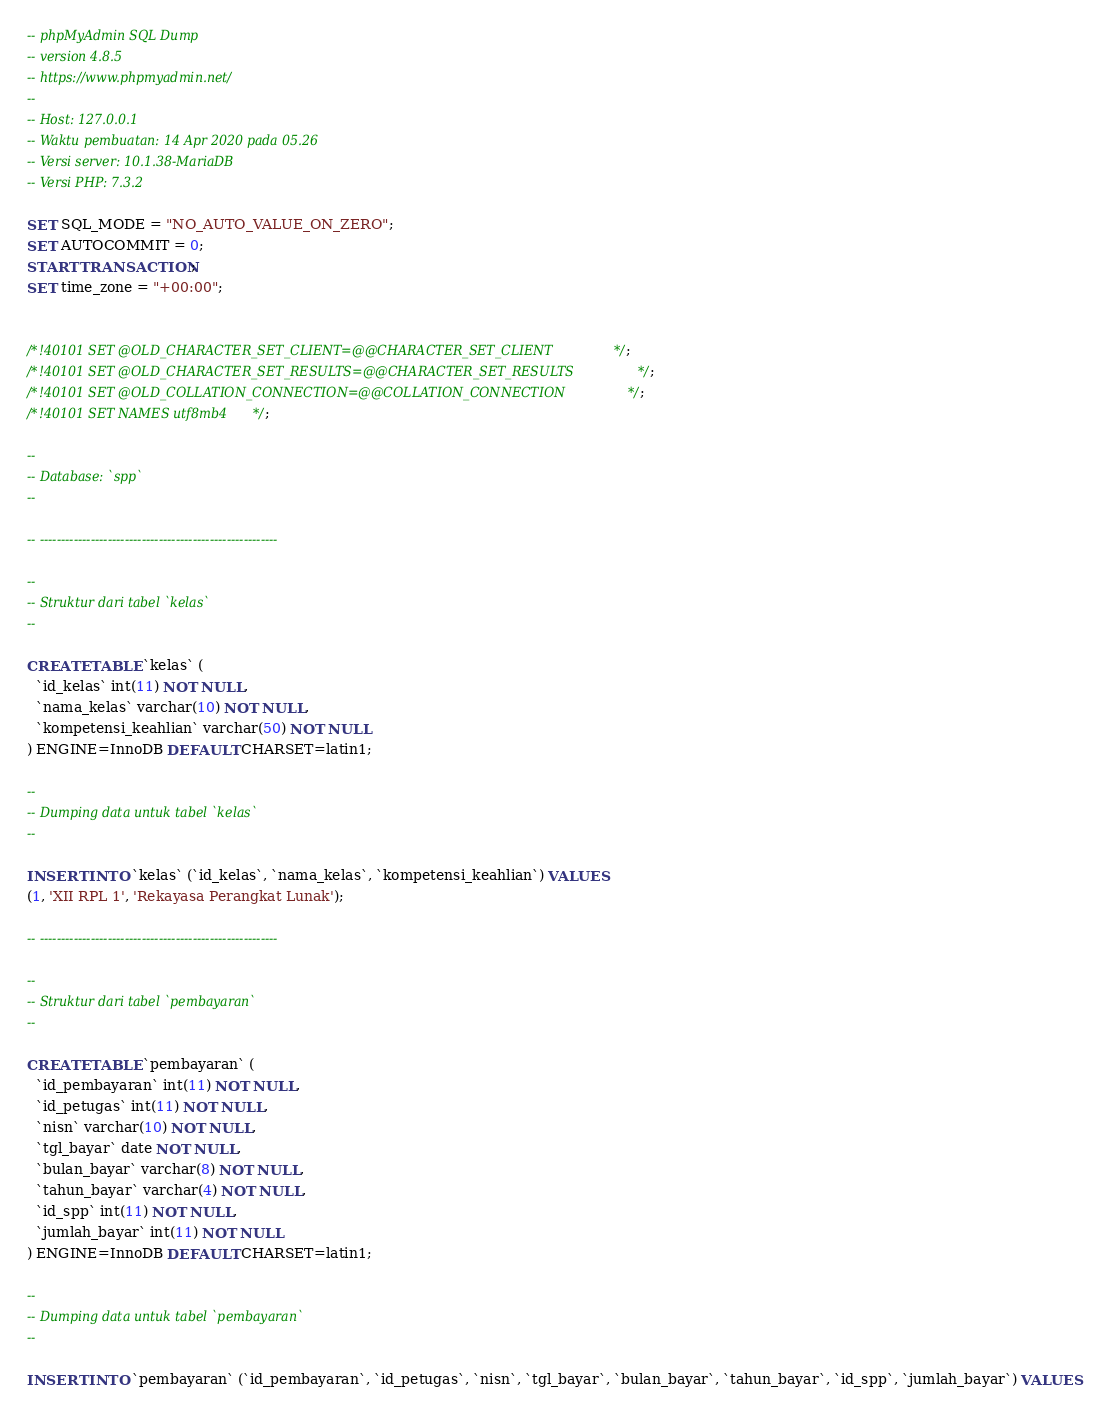<code> <loc_0><loc_0><loc_500><loc_500><_SQL_>-- phpMyAdmin SQL Dump
-- version 4.8.5
-- https://www.phpmyadmin.net/
--
-- Host: 127.0.0.1
-- Waktu pembuatan: 14 Apr 2020 pada 05.26
-- Versi server: 10.1.38-MariaDB
-- Versi PHP: 7.3.2

SET SQL_MODE = "NO_AUTO_VALUE_ON_ZERO";
SET AUTOCOMMIT = 0;
START TRANSACTION;
SET time_zone = "+00:00";


/*!40101 SET @OLD_CHARACTER_SET_CLIENT=@@CHARACTER_SET_CLIENT */;
/*!40101 SET @OLD_CHARACTER_SET_RESULTS=@@CHARACTER_SET_RESULTS */;
/*!40101 SET @OLD_COLLATION_CONNECTION=@@COLLATION_CONNECTION */;
/*!40101 SET NAMES utf8mb4 */;

--
-- Database: `spp`
--

-- --------------------------------------------------------

--
-- Struktur dari tabel `kelas`
--

CREATE TABLE `kelas` (
  `id_kelas` int(11) NOT NULL,
  `nama_kelas` varchar(10) NOT NULL,
  `kompetensi_keahlian` varchar(50) NOT NULL
) ENGINE=InnoDB DEFAULT CHARSET=latin1;

--
-- Dumping data untuk tabel `kelas`
--

INSERT INTO `kelas` (`id_kelas`, `nama_kelas`, `kompetensi_keahlian`) VALUES
(1, 'XII RPL 1', 'Rekayasa Perangkat Lunak');

-- --------------------------------------------------------

--
-- Struktur dari tabel `pembayaran`
--

CREATE TABLE `pembayaran` (
  `id_pembayaran` int(11) NOT NULL,
  `id_petugas` int(11) NOT NULL,
  `nisn` varchar(10) NOT NULL,
  `tgl_bayar` date NOT NULL,
  `bulan_bayar` varchar(8) NOT NULL,
  `tahun_bayar` varchar(4) NOT NULL,
  `id_spp` int(11) NOT NULL,
  `jumlah_bayar` int(11) NOT NULL
) ENGINE=InnoDB DEFAULT CHARSET=latin1;

--
-- Dumping data untuk tabel `pembayaran`
--

INSERT INTO `pembayaran` (`id_pembayaran`, `id_petugas`, `nisn`, `tgl_bayar`, `bulan_bayar`, `tahun_bayar`, `id_spp`, `jumlah_bayar`) VALUES</code> 